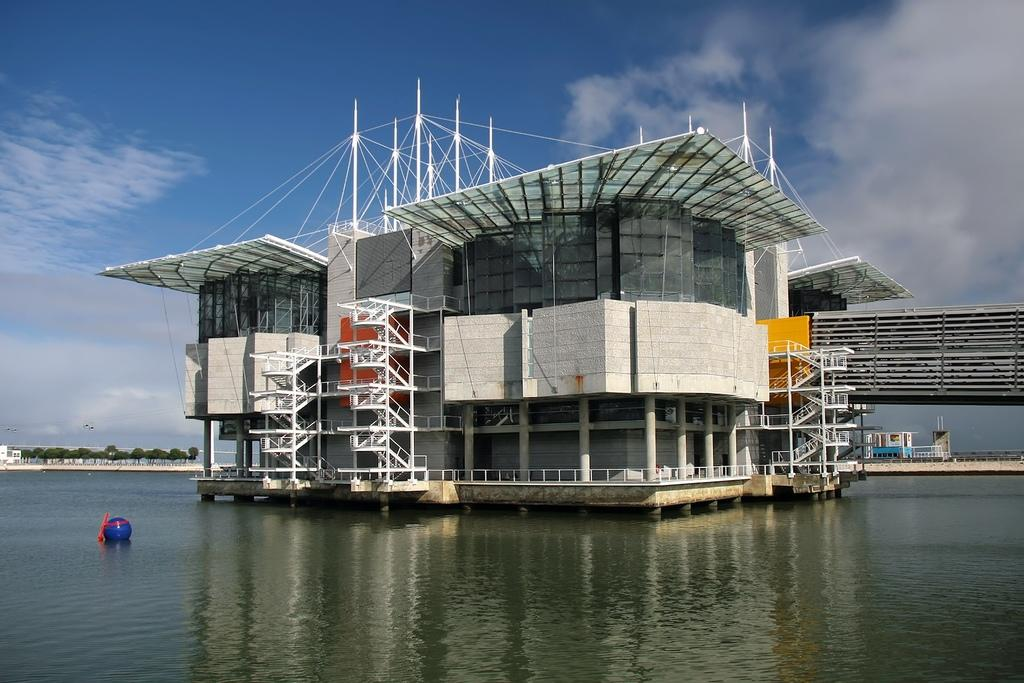What is the primary element in the image? There is water in the image. What structure can be seen in the water? There is a building with pillars in the water. What architectural features are present in the building? The building has staircases and poles. What can be seen in the background of the image? The sky and trees are visible in the background of the image. What color is the object in the water? There is a blue color thing in the water. What type of quilt is being used to cover the tub in the image? There is no tub or quilt present in the image. 